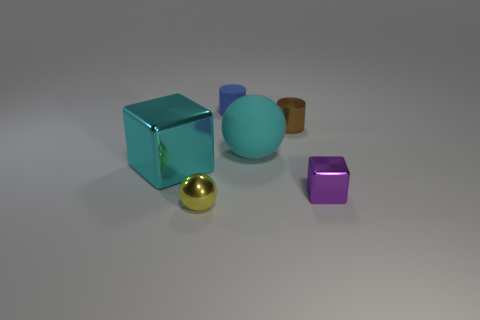Add 4 brown metal objects. How many objects exist? 10 Subtract all cylinders. How many objects are left? 4 Add 2 purple shiny cubes. How many purple shiny cubes exist? 3 Subtract 1 brown cylinders. How many objects are left? 5 Subtract all brown cylinders. Subtract all cyan rubber balls. How many objects are left? 4 Add 3 small metal spheres. How many small metal spheres are left? 4 